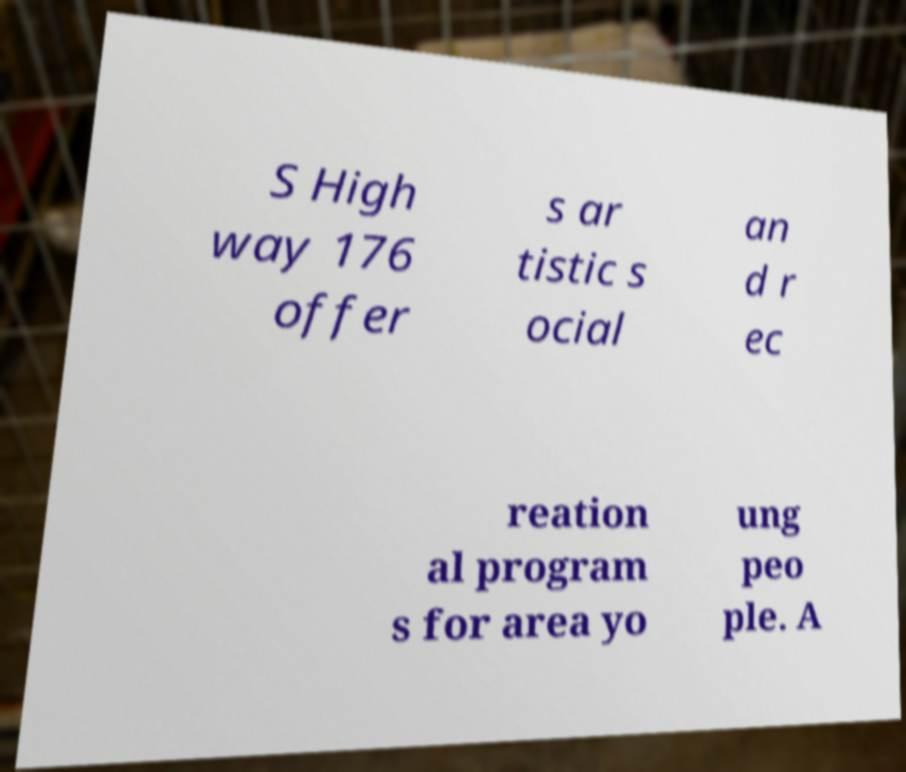Can you accurately transcribe the text from the provided image for me? S High way 176 offer s ar tistic s ocial an d r ec reation al program s for area yo ung peo ple. A 